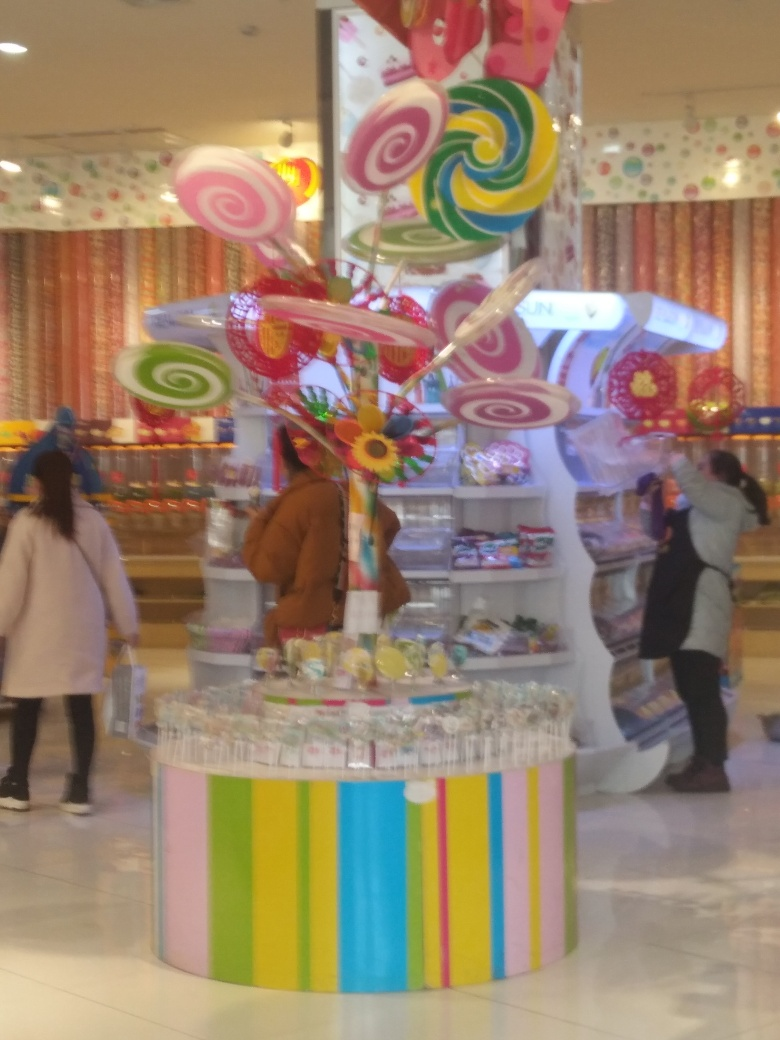Could this be a special event or a regular setup for this venue? It looks like a regular setup for a candy store that specializes in decorative sweets and treats, designed to attract customers with its eye-catching and playful decor. What kind of products seem to be on offer here? The product range includes a variety of candies, such as lollipops, jelly beans, and possibly chocolate, all presented in a way that emphasizes fun and variety, likely catering to both children and adults looking for a sweet indulgence. 